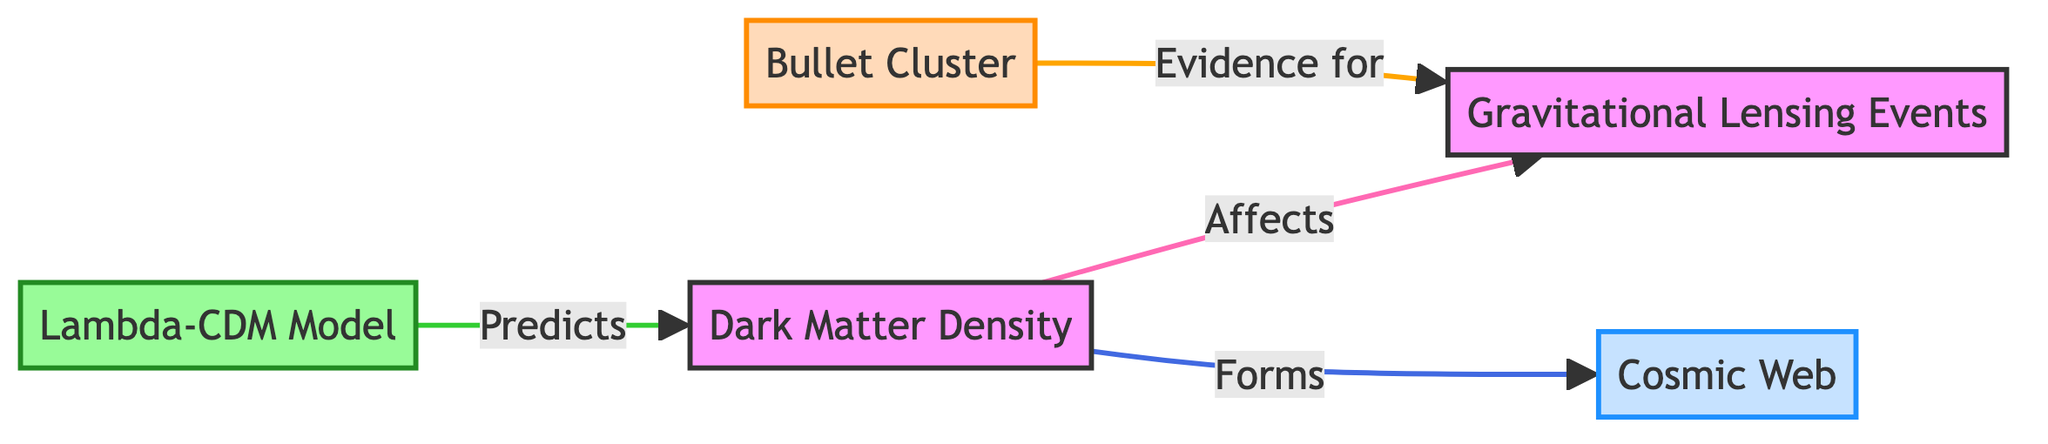What is mapped in relation to Dark Matter Density? The diagram indicates that Gravitational Lensing Events are affected by Dark Matter Density, which is shown as a direct link between the two nodes.
Answer: Gravitational Lensing Events How many nodes are present in the diagram? There are five nodes in the diagram: Dark Matter Density, Gravitational Lensing Events, Cosmic Web, Bullet Cluster, and Lambda-CDM Model. By counting them, we confirm there are five distinct entities represented.
Answer: Five What does the Lambda-CDM Model predict? From the diagram, it shows that the Lambda-CDM Model predicts Dark Matter Density, as indicated by the directional arrow from the Lambda-CDM Model to Dark Matter Density.
Answer: Dark Matter Density Which event provides evidence for Gravitational Lensing? The Bullet Cluster is noted in the diagram with a direct connection as evidence for Gravitational Lensing Events, highlighting its importance in the context of dark matter research.
Answer: Bullet Cluster What relationship does Dark Matter Density have with Cosmic Web? It is stated in the diagram that Dark Matter Density forms the Cosmic Web, indicating a foundational role of dark matter in the large-scale structure of the universe.
Answer: Forms How many types of links are represented in the diagram? The diagram contains four distinct types of links that are colored and specify different interactions: affects, forms, evidence for, and predicts. This shows the variety of relationships represented.
Answer: Four 